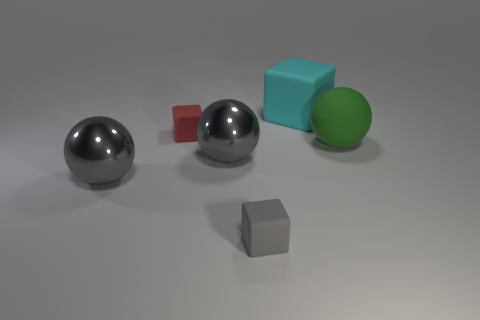What material is the cyan block that is the same size as the green thing? The cyan block appears to be made of a rubber-like material, sharing the same matte finish and soft edges typical for rubber objects in contrast to the metallic sheen of the spheres and the harder edges of the gray cube. 